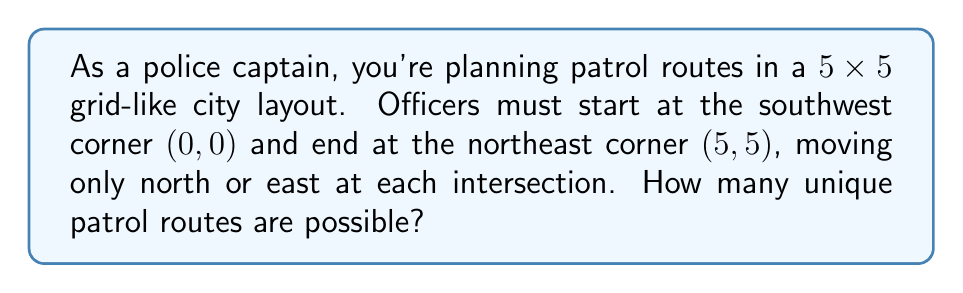Help me with this question. Let's approach this step-by-step:

1) This problem is equivalent to finding the number of ways to arrange 5 east moves and 5 north moves in a sequence.

2) The total number of moves is always 10 (5 east + 5 north).

3) We can use the combination formula to solve this:
   
   $${10 \choose 5} = \frac{10!}{5!(10-5)!} = \frac{10!}{5!5!}$$

4) Expanding this:
   
   $$\frac{10 \times 9 \times 8 \times 7 \times 6 \times 5!}{5! \times 5 \times 4 \times 3 \times 2 \times 1}$$

5) The 5! cancels out in the numerator and denominator:
   
   $$\frac{10 \times 9 \times 8 \times 7 \times 6}{5 \times 4 \times 3 \times 2 \times 1}$$

6) Multiplying the numerator and denominator:
   
   $$\frac{30240}{120} = 252$$

Therefore, there are 252 unique patrol routes possible.
Answer: 252 